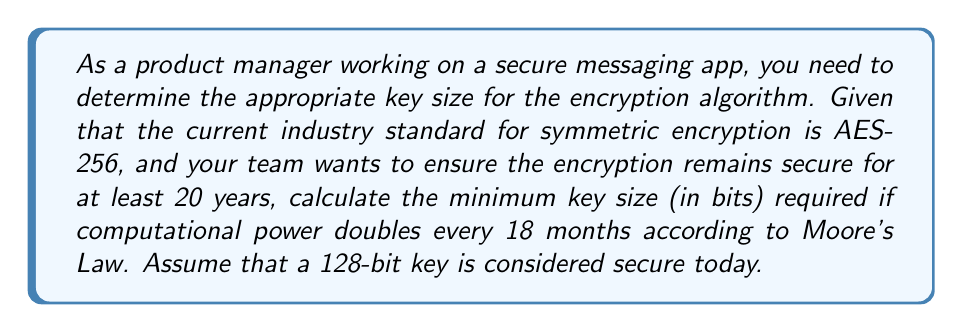Help me with this question. To solve this problem, we'll follow these steps:

1. Determine the number of times computational power will double in 20 years:
   - 20 years = 240 months
   - Number of doublings = 240 months ÷ 18 months = 13.33

2. Calculate the total increase in computational power:
   $$2^{13.33} \approx 10,321$$

3. Determine the additional key bits needed to maintain security:
   - We need to add $\log_2(10,321)$ bits to the current 128-bit key
   $$\log_2(10,321) \approx 13.33$$

4. Calculate the total required key size:
   $$128 + 13.33 \approx 141.33$$

5. Round up to the nearest whole number of bits:
   $$\lceil 141.33 \rceil = 142$$

Therefore, the minimum key size required to maintain security for the next 20 years is 142 bits.

However, in practice, key sizes are typically powers of 2 for efficiency. The next power of 2 above 142 is 256, which aligns with the current AES-256 standard mentioned in the question.
Answer: 256 bits 